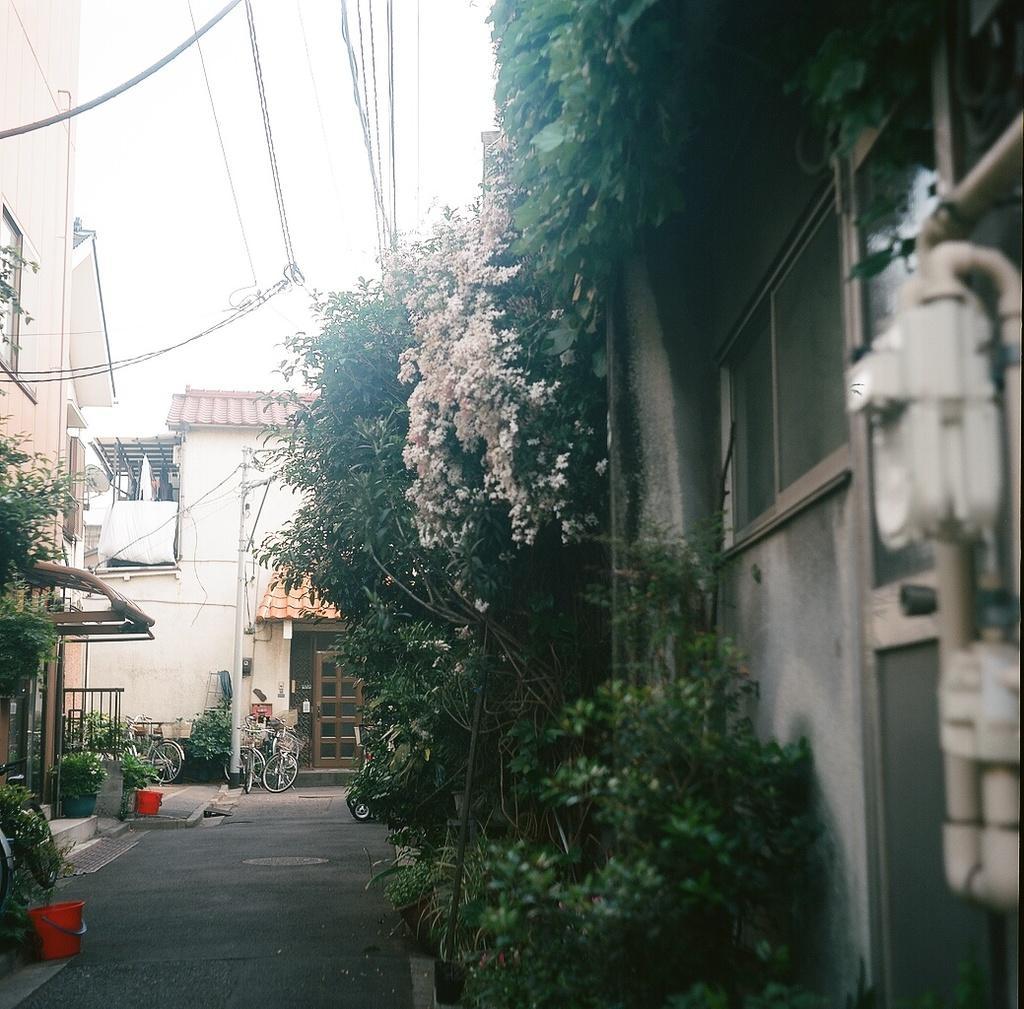How would you summarize this image in a sentence or two? In this picture we can see the road, bicycles, trees, flowers, buildings, wires, some objects and in the background we can see the sky. 